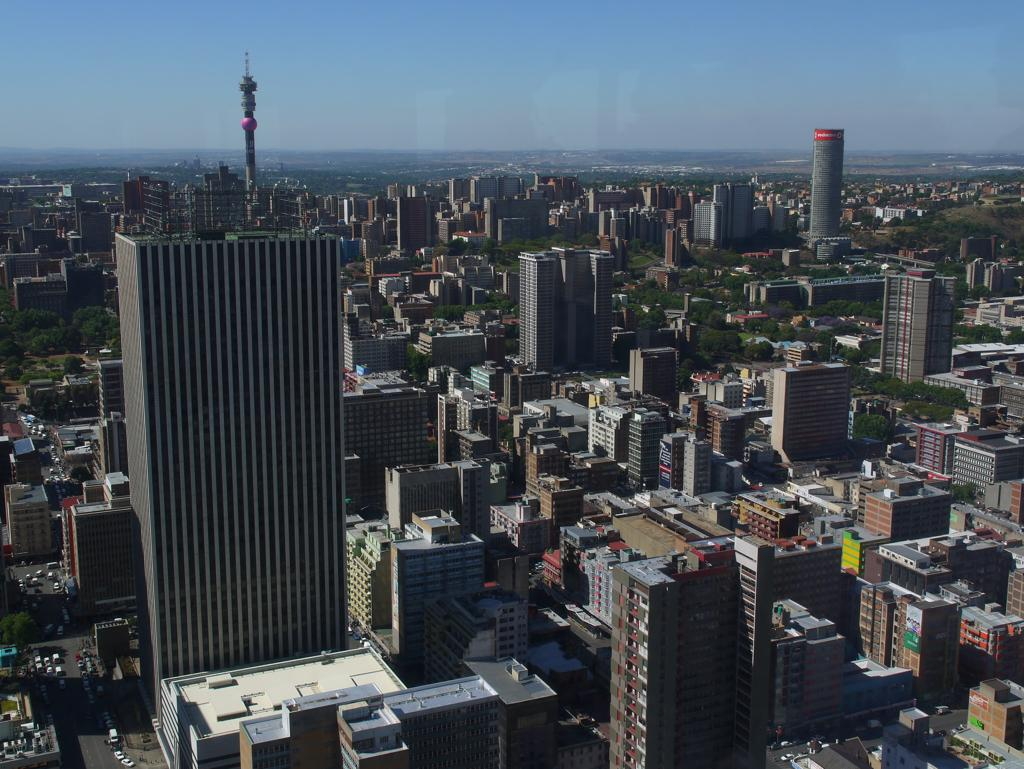What type of structures can be seen in the image? There are buildings in the image. What is happening on the road in the bottom left of the image? There are vehicles on the road in the bottom left of the image. What type of vegetation is present in the image? There are trees in the image. What is visible at the top of the image? The sky is visible at the top of the image. Can you tell me the position of the wren in the image? There is no wren present in the image. What type of meal is being prepared in the image? There is no meal preparation visible in the image. 